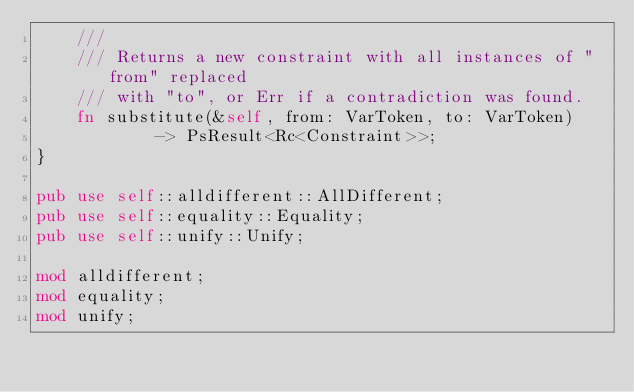Convert code to text. <code><loc_0><loc_0><loc_500><loc_500><_Rust_>    ///
    /// Returns a new constraint with all instances of "from" replaced
    /// with "to", or Err if a contradiction was found.
    fn substitute(&self, from: VarToken, to: VarToken)
            -> PsResult<Rc<Constraint>>;
}

pub use self::alldifferent::AllDifferent;
pub use self::equality::Equality;
pub use self::unify::Unify;

mod alldifferent;
mod equality;
mod unify;
</code> 